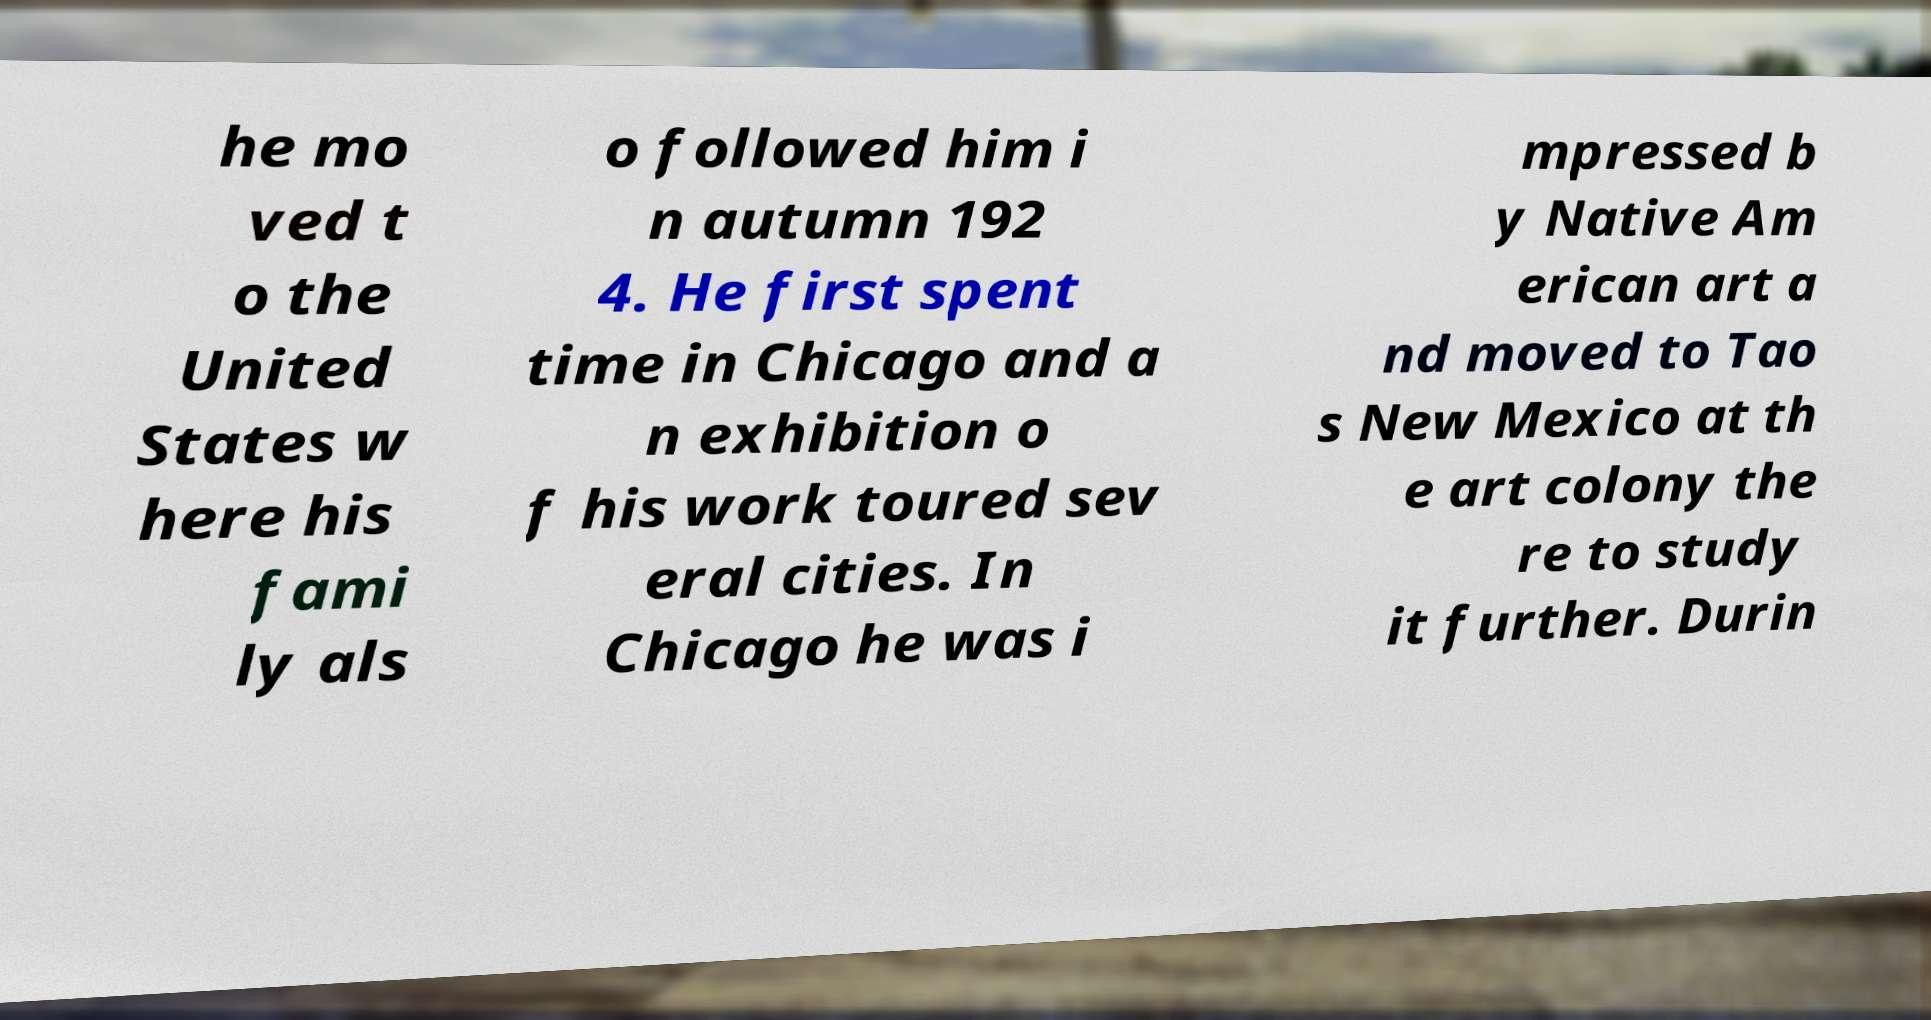Please identify and transcribe the text found in this image. he mo ved t o the United States w here his fami ly als o followed him i n autumn 192 4. He first spent time in Chicago and a n exhibition o f his work toured sev eral cities. In Chicago he was i mpressed b y Native Am erican art a nd moved to Tao s New Mexico at th e art colony the re to study it further. Durin 